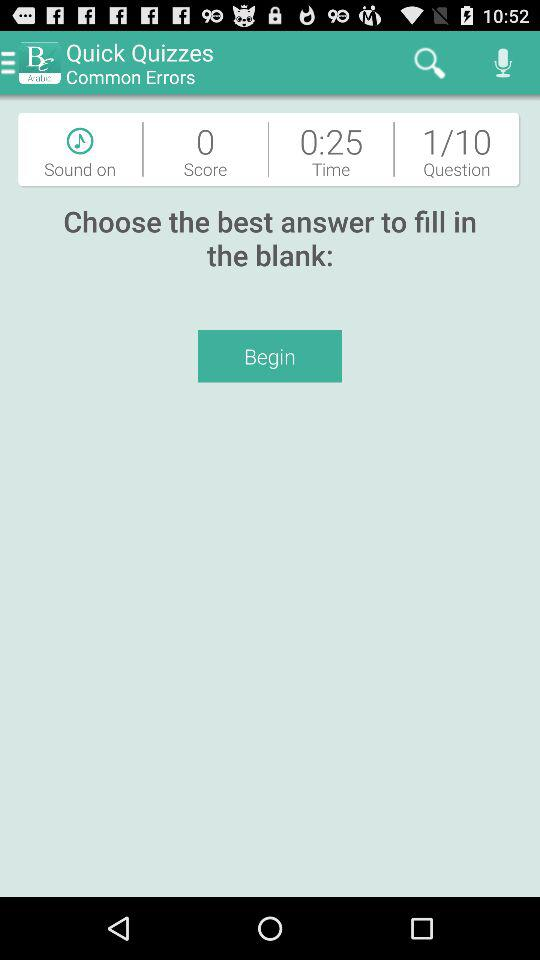What is the score? The score is 0. 